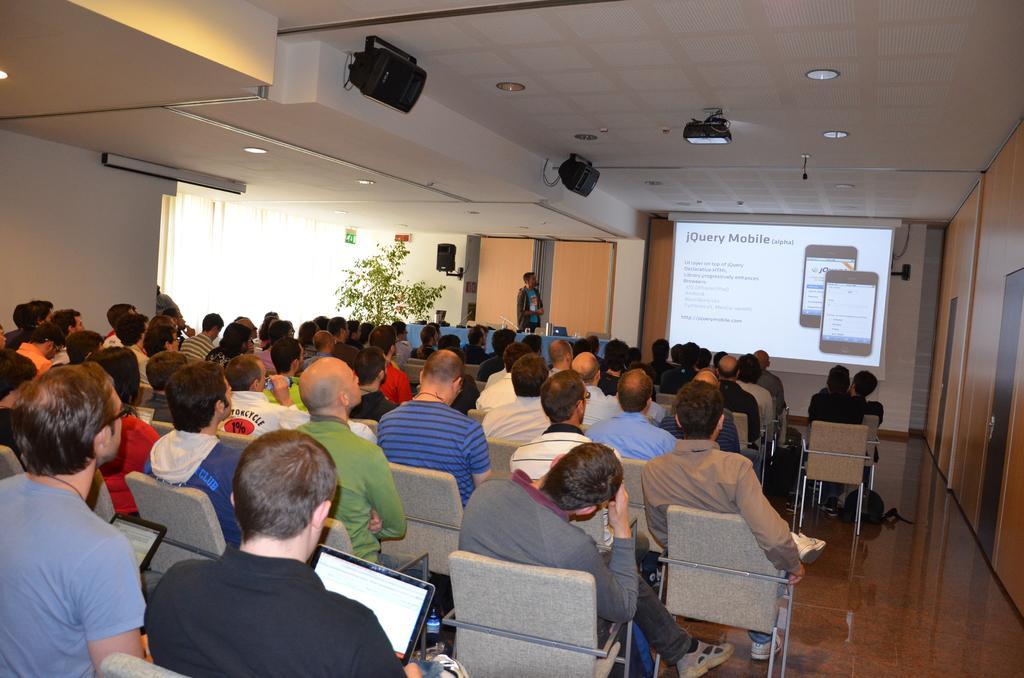Please provide a concise description of this image. This picture is clicked in the conference hall. In this picture, we see many people sitting on the chairs. The man in the black T-shirt is sitting on the chair and holding a laptop in his hands. In front of them, we see the man in grey jacket is standing on the stage. In front of him, we see a table which is covered with a blue cover sheet. On the table, we see water glass and a water bottle. Beside the table, we see a flower pot and a white curtain. In the background, we see the projector screen displaying something. Beside that, we see the wall in orange color. At the top of the picture, we see the ceiling of the room. 